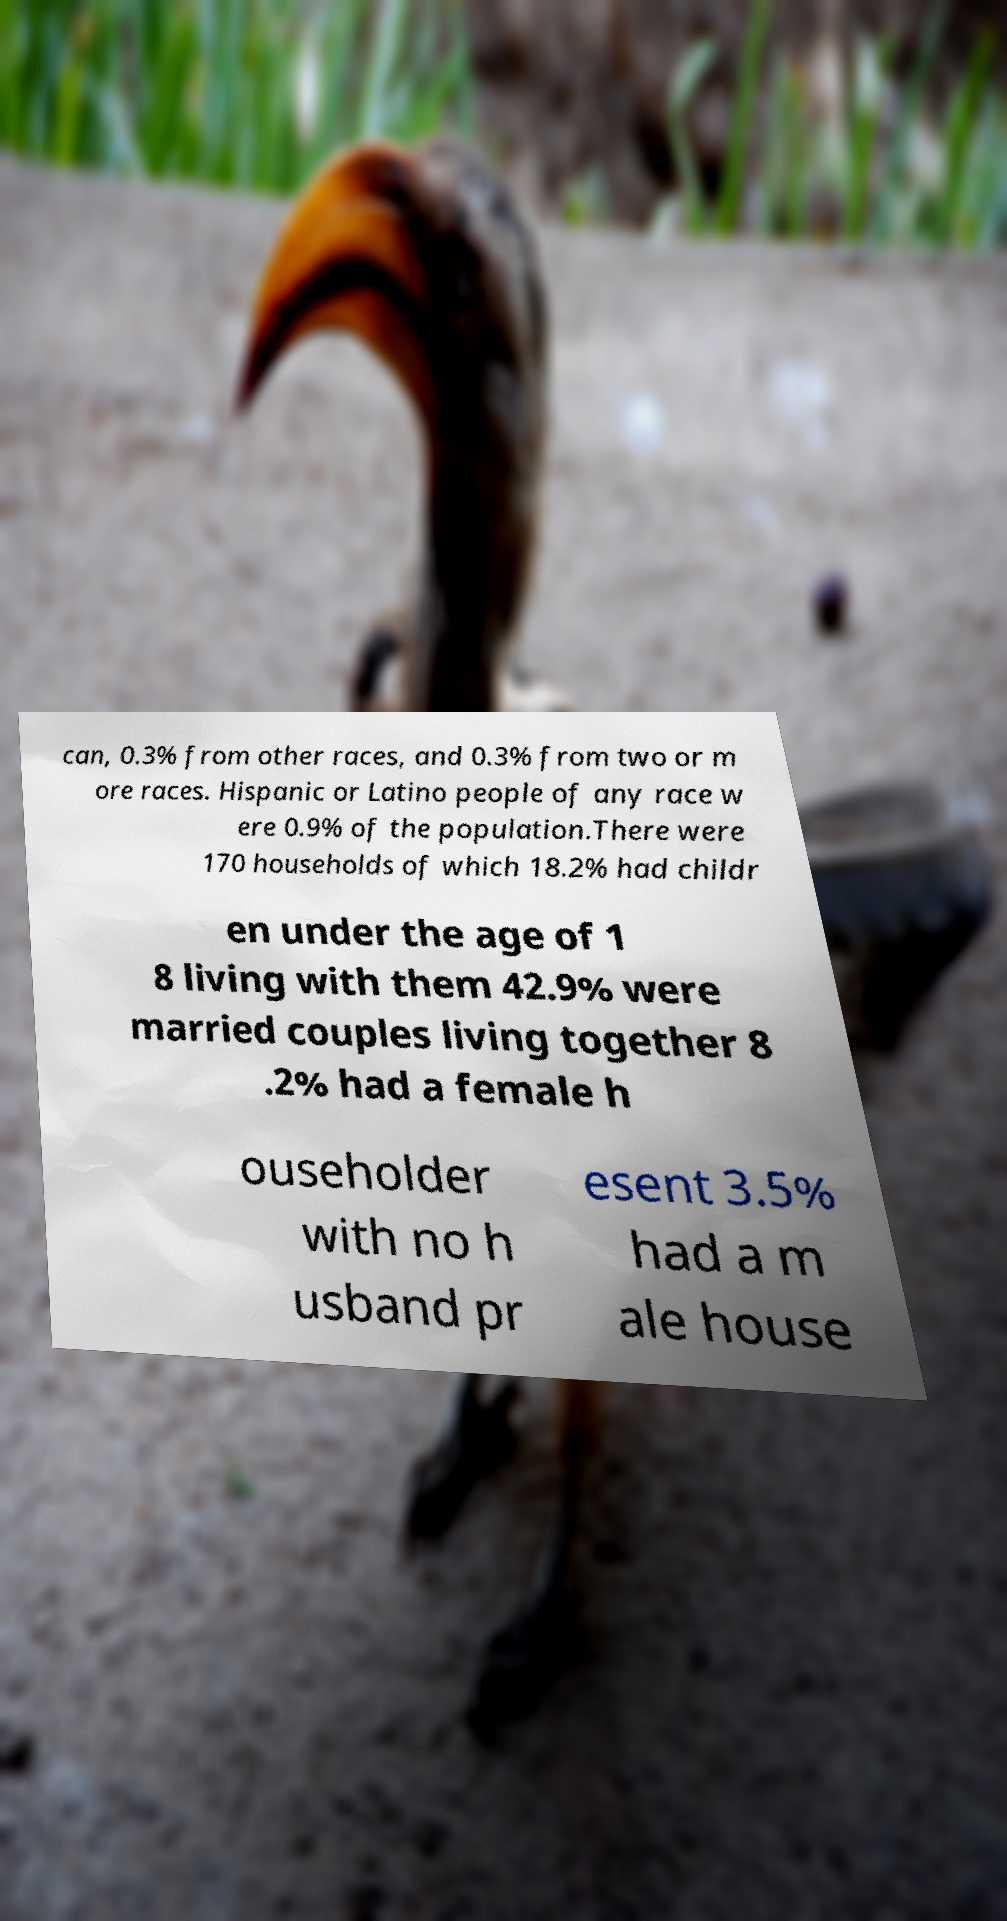Could you extract and type out the text from this image? can, 0.3% from other races, and 0.3% from two or m ore races. Hispanic or Latino people of any race w ere 0.9% of the population.There were 170 households of which 18.2% had childr en under the age of 1 8 living with them 42.9% were married couples living together 8 .2% had a female h ouseholder with no h usband pr esent 3.5% had a m ale house 